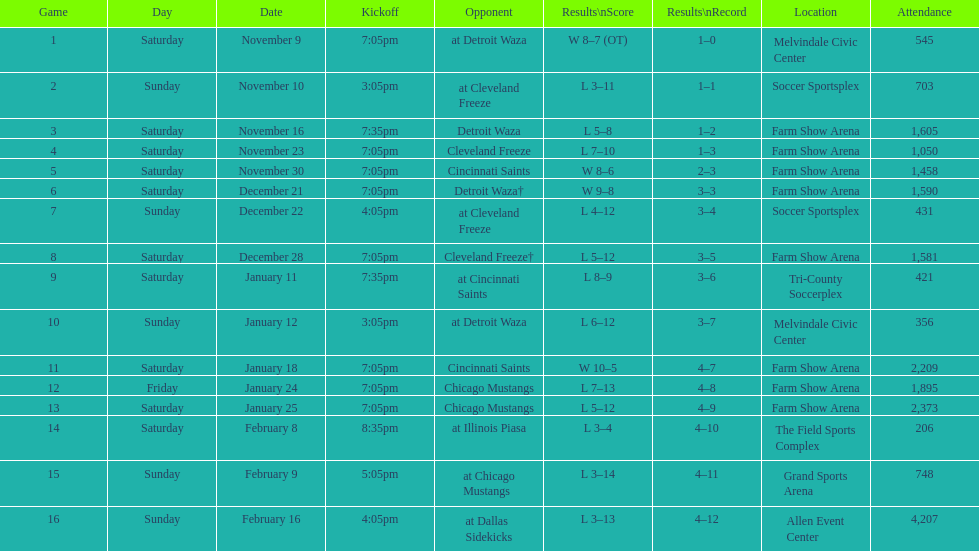In how many matches did the harrisburg heat achieve victory where they scored eight or more goals? 4. 